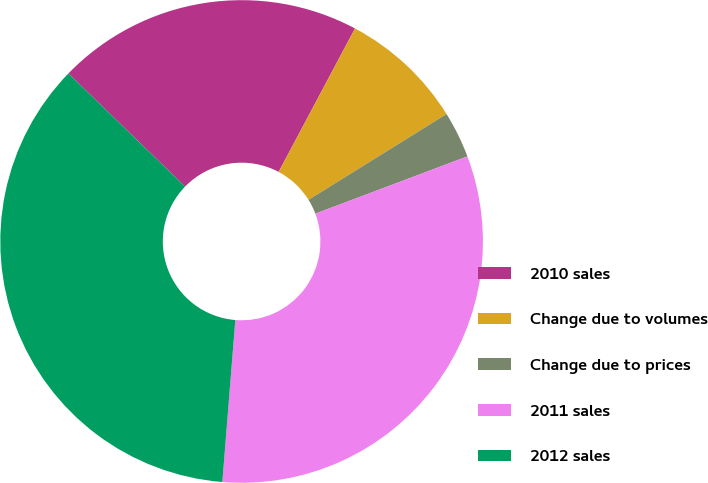Convert chart. <chart><loc_0><loc_0><loc_500><loc_500><pie_chart><fcel>2010 sales<fcel>Change due to volumes<fcel>Change due to prices<fcel>2011 sales<fcel>2012 sales<nl><fcel>20.53%<fcel>8.36%<fcel>3.12%<fcel>32.01%<fcel>35.99%<nl></chart> 